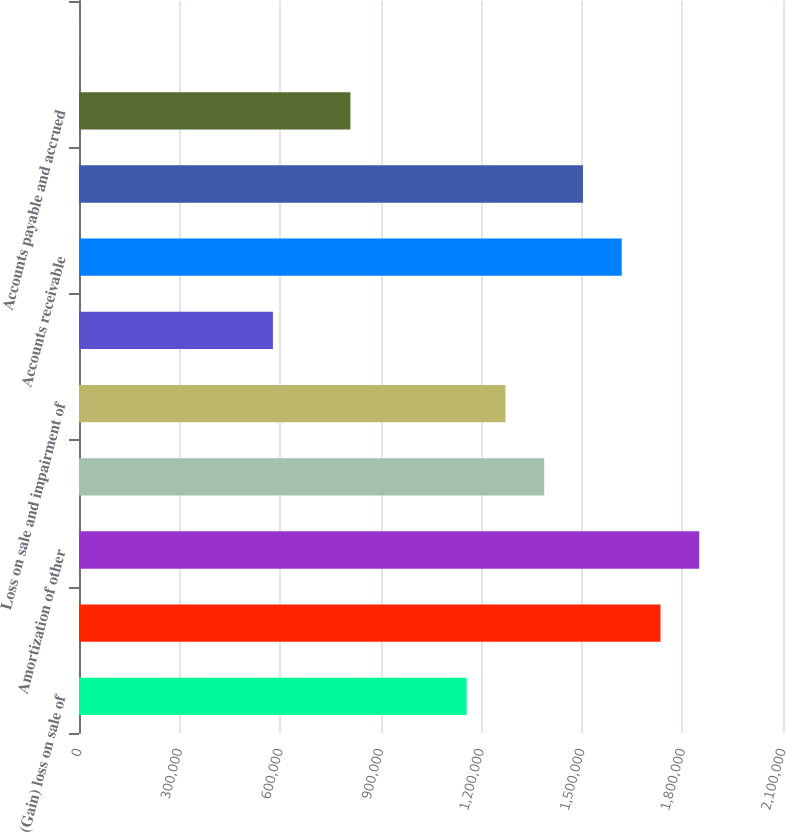<chart> <loc_0><loc_0><loc_500><loc_500><bar_chart><fcel>(Gain) loss on sale of<fcel>Depreciation of property and<fcel>Amortization of other<fcel>Stock-based compensation<fcel>Loss on sale and impairment of<fcel>Other net<fcel>Accounts receivable<fcel>Prepaid expenses and other<fcel>Accounts payable and accrued<fcel>Accrued restructuring costs<nl><fcel>1.15649e+06<fcel>1.73453e+06<fcel>1.85014e+06<fcel>1.38771e+06<fcel>1.2721e+06<fcel>578448<fcel>1.61893e+06<fcel>1.50332e+06<fcel>809665<fcel>404<nl></chart> 